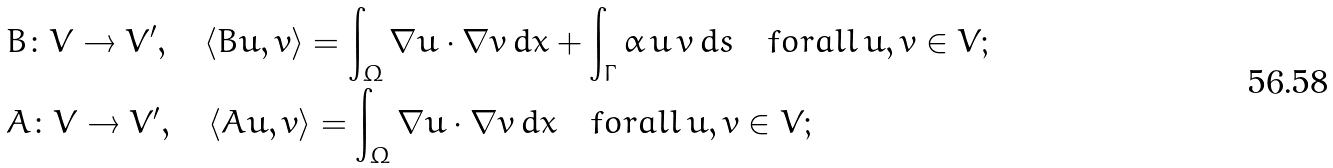Convert formula to latex. <formula><loc_0><loc_0><loc_500><loc_500>& B \colon V \rightarrow V ^ { \prime } , \quad \langle B u , v \rangle = \int _ { \Omega } { \nabla u \cdot \nabla v \, d x } + \int _ { \Gamma } { \alpha \, u \, v \, d s } \quad f o r a l l \, u , v \in V ; \\ & A \colon V \rightarrow V ^ { \prime } , \quad \langle A u , v \rangle = \int _ { \Omega } { \nabla u \cdot \nabla v \, d x } \quad f o r a l l \, u , v \in V ;</formula> 